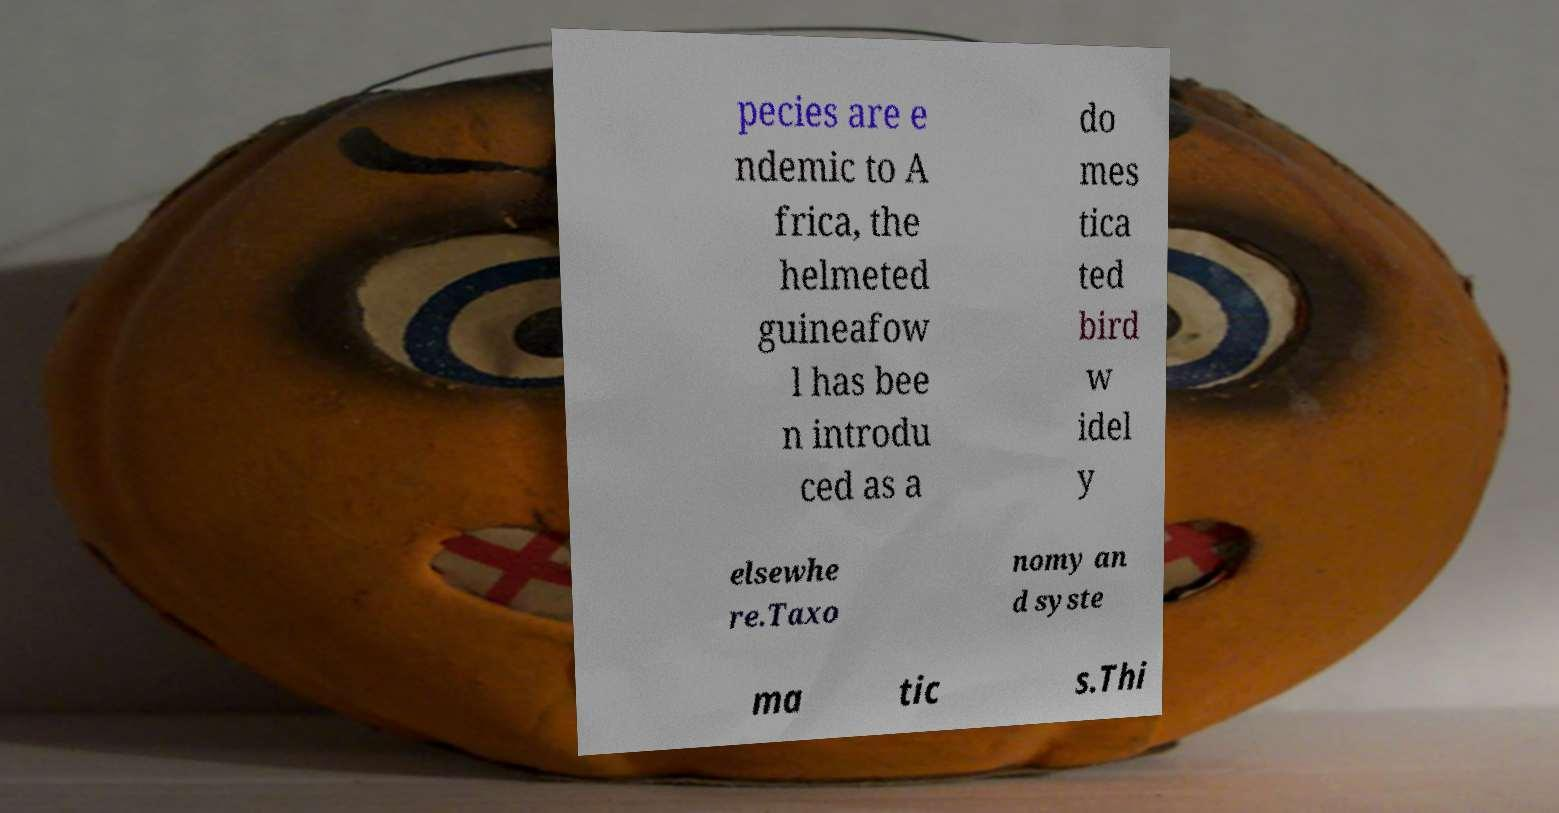For documentation purposes, I need the text within this image transcribed. Could you provide that? pecies are e ndemic to A frica, the helmeted guineafow l has bee n introdu ced as a do mes tica ted bird w idel y elsewhe re.Taxo nomy an d syste ma tic s.Thi 